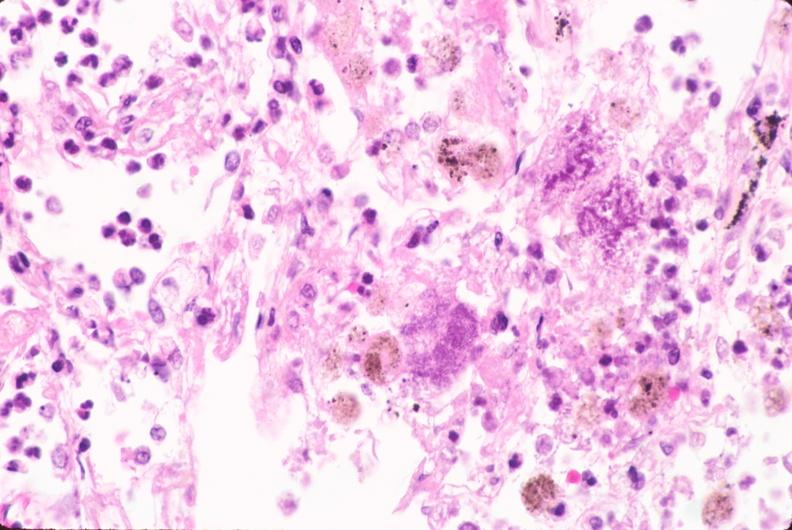does this image show lung, bronchopneumonia, bacterial?
Answer the question using a single word or phrase. Yes 